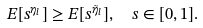<formula> <loc_0><loc_0><loc_500><loc_500>E [ s ^ { \eta _ { l } } ] & \geq E [ s ^ { \tilde { \eta } _ { l } } ] , \quad s \in [ 0 , 1 ] .</formula> 